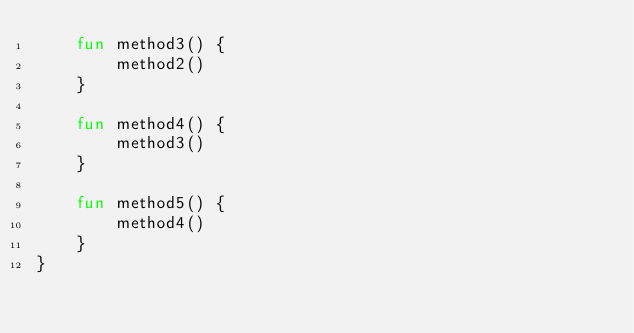Convert code to text. <code><loc_0><loc_0><loc_500><loc_500><_Kotlin_>    fun method3() {
        method2()
    }

    fun method4() {
        method3()
    }

    fun method5() {
        method4()
    }
}
</code> 